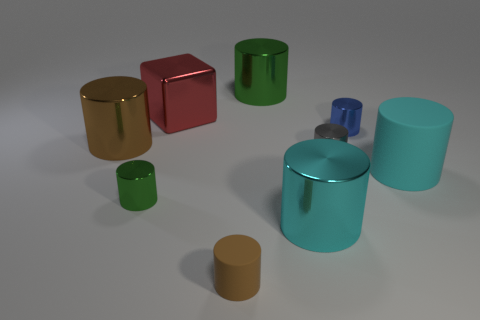Add 1 tiny blocks. How many objects exist? 10 Subtract all cubes. How many objects are left? 8 Subtract 1 blocks. How many blocks are left? 0 Subtract all brown blocks. Subtract all brown cylinders. How many blocks are left? 1 Subtract all cyan cylinders. How many cyan cubes are left? 0 Subtract all big brown shiny objects. Subtract all brown metal spheres. How many objects are left? 8 Add 5 rubber objects. How many rubber objects are left? 7 Add 5 big red metallic things. How many big red metallic things exist? 6 Subtract all gray cylinders. How many cylinders are left? 7 Subtract all metallic cylinders. How many cylinders are left? 2 